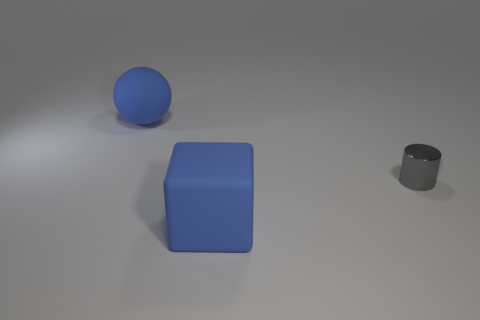Add 1 small gray metal things. How many objects exist? 4 Subtract all spheres. How many objects are left? 2 Subtract 0 red spheres. How many objects are left? 3 Subtract all tiny gray things. Subtract all gray cylinders. How many objects are left? 1 Add 2 large cubes. How many large cubes are left? 3 Add 2 large rubber things. How many large rubber things exist? 4 